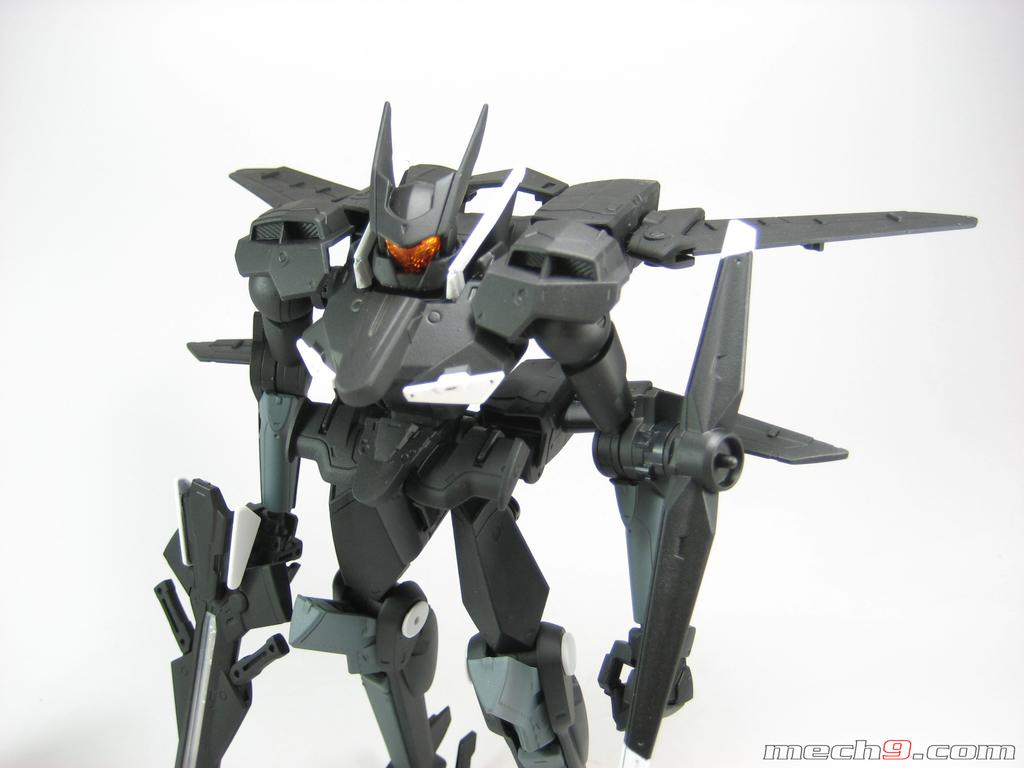What is the main subject of the image? The main subject of the image is a toy robot. What color is the background of the image? The background of the image is white. How many clocks are visible on the toy robot in the image? There are no clocks visible on the toy robot in the image. What type of trouble is the toy robot causing in the image? There is no indication of any trouble caused by the toy robot in the image. What kind of marble is used to construct the toy robot in the image? There is no marble used to construct the toy robot in the image; it is a toy made of other materials. 